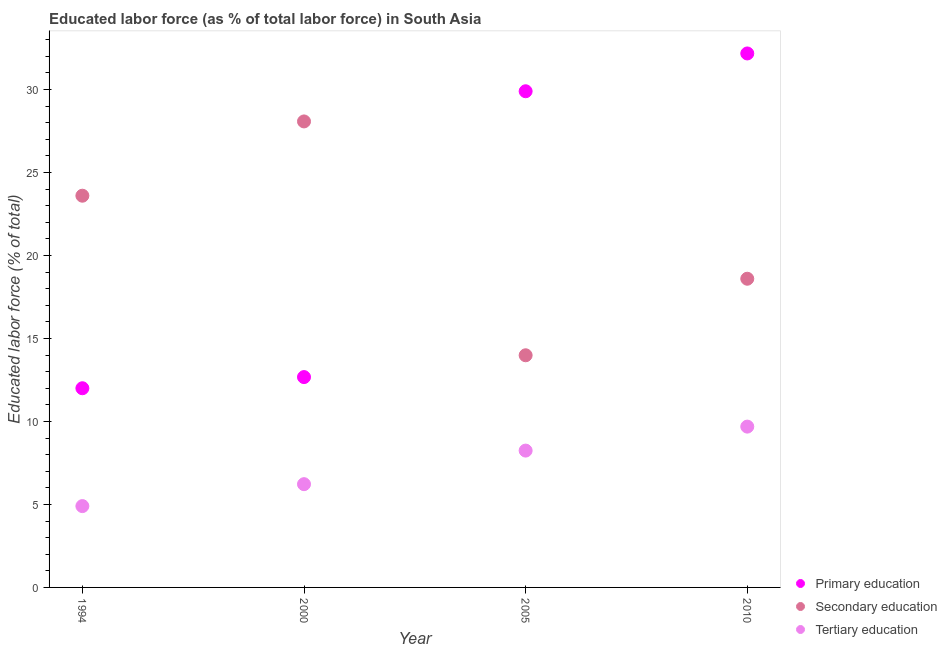How many different coloured dotlines are there?
Ensure brevity in your answer.  3. Is the number of dotlines equal to the number of legend labels?
Offer a very short reply. Yes. What is the percentage of labor force who received secondary education in 1994?
Keep it short and to the point. 23.6. Across all years, what is the maximum percentage of labor force who received secondary education?
Offer a terse response. 28.08. In which year was the percentage of labor force who received tertiary education maximum?
Provide a succinct answer. 2010. In which year was the percentage of labor force who received tertiary education minimum?
Ensure brevity in your answer.  1994. What is the total percentage of labor force who received tertiary education in the graph?
Ensure brevity in your answer.  29.05. What is the difference between the percentage of labor force who received secondary education in 1994 and that in 2010?
Make the answer very short. 5. What is the difference between the percentage of labor force who received primary education in 1994 and the percentage of labor force who received secondary education in 2010?
Keep it short and to the point. -6.6. What is the average percentage of labor force who received secondary education per year?
Ensure brevity in your answer.  21.06. In the year 2010, what is the difference between the percentage of labor force who received secondary education and percentage of labor force who received primary education?
Provide a succinct answer. -13.57. In how many years, is the percentage of labor force who received tertiary education greater than 12 %?
Provide a short and direct response. 0. What is the ratio of the percentage of labor force who received primary education in 2005 to that in 2010?
Your answer should be compact. 0.93. What is the difference between the highest and the second highest percentage of labor force who received tertiary education?
Make the answer very short. 1.45. What is the difference between the highest and the lowest percentage of labor force who received secondary education?
Your answer should be compact. 14.09. In how many years, is the percentage of labor force who received primary education greater than the average percentage of labor force who received primary education taken over all years?
Your answer should be very brief. 2. Is the sum of the percentage of labor force who received tertiary education in 1994 and 2005 greater than the maximum percentage of labor force who received secondary education across all years?
Your answer should be compact. No. Does the percentage of labor force who received tertiary education monotonically increase over the years?
Your answer should be compact. Yes. Is the percentage of labor force who received secondary education strictly greater than the percentage of labor force who received primary education over the years?
Provide a short and direct response. No. Is the percentage of labor force who received primary education strictly less than the percentage of labor force who received tertiary education over the years?
Your answer should be compact. No. How many dotlines are there?
Make the answer very short. 3. How many years are there in the graph?
Your response must be concise. 4. Does the graph contain any zero values?
Give a very brief answer. No. How many legend labels are there?
Your answer should be compact. 3. What is the title of the graph?
Give a very brief answer. Educated labor force (as % of total labor force) in South Asia. What is the label or title of the Y-axis?
Provide a succinct answer. Educated labor force (% of total). What is the Educated labor force (% of total) in Secondary education in 1994?
Give a very brief answer. 23.6. What is the Educated labor force (% of total) in Tertiary education in 1994?
Keep it short and to the point. 4.9. What is the Educated labor force (% of total) in Primary education in 2000?
Ensure brevity in your answer.  12.67. What is the Educated labor force (% of total) in Secondary education in 2000?
Provide a short and direct response. 28.08. What is the Educated labor force (% of total) in Tertiary education in 2000?
Give a very brief answer. 6.22. What is the Educated labor force (% of total) of Primary education in 2005?
Your answer should be very brief. 29.89. What is the Educated labor force (% of total) of Secondary education in 2005?
Keep it short and to the point. 13.99. What is the Educated labor force (% of total) in Tertiary education in 2005?
Provide a short and direct response. 8.24. What is the Educated labor force (% of total) in Primary education in 2010?
Your answer should be very brief. 32.17. What is the Educated labor force (% of total) of Secondary education in 2010?
Make the answer very short. 18.6. What is the Educated labor force (% of total) of Tertiary education in 2010?
Your answer should be very brief. 9.69. Across all years, what is the maximum Educated labor force (% of total) of Primary education?
Provide a succinct answer. 32.17. Across all years, what is the maximum Educated labor force (% of total) in Secondary education?
Offer a terse response. 28.08. Across all years, what is the maximum Educated labor force (% of total) of Tertiary education?
Keep it short and to the point. 9.69. Across all years, what is the minimum Educated labor force (% of total) in Primary education?
Keep it short and to the point. 12. Across all years, what is the minimum Educated labor force (% of total) of Secondary education?
Your response must be concise. 13.99. Across all years, what is the minimum Educated labor force (% of total) in Tertiary education?
Provide a succinct answer. 4.9. What is the total Educated labor force (% of total) of Primary education in the graph?
Provide a succinct answer. 86.74. What is the total Educated labor force (% of total) of Secondary education in the graph?
Your answer should be very brief. 84.26. What is the total Educated labor force (% of total) in Tertiary education in the graph?
Your response must be concise. 29.05. What is the difference between the Educated labor force (% of total) of Primary education in 1994 and that in 2000?
Provide a short and direct response. -0.67. What is the difference between the Educated labor force (% of total) in Secondary education in 1994 and that in 2000?
Offer a terse response. -4.48. What is the difference between the Educated labor force (% of total) of Tertiary education in 1994 and that in 2000?
Your response must be concise. -1.32. What is the difference between the Educated labor force (% of total) in Primary education in 1994 and that in 2005?
Offer a terse response. -17.89. What is the difference between the Educated labor force (% of total) of Secondary education in 1994 and that in 2005?
Give a very brief answer. 9.61. What is the difference between the Educated labor force (% of total) of Tertiary education in 1994 and that in 2005?
Offer a terse response. -3.34. What is the difference between the Educated labor force (% of total) of Primary education in 1994 and that in 2010?
Provide a short and direct response. -20.17. What is the difference between the Educated labor force (% of total) in Secondary education in 1994 and that in 2010?
Provide a short and direct response. 5. What is the difference between the Educated labor force (% of total) of Tertiary education in 1994 and that in 2010?
Make the answer very short. -4.79. What is the difference between the Educated labor force (% of total) in Primary education in 2000 and that in 2005?
Keep it short and to the point. -17.22. What is the difference between the Educated labor force (% of total) in Secondary education in 2000 and that in 2005?
Provide a short and direct response. 14.09. What is the difference between the Educated labor force (% of total) of Tertiary education in 2000 and that in 2005?
Your response must be concise. -2.02. What is the difference between the Educated labor force (% of total) of Primary education in 2000 and that in 2010?
Ensure brevity in your answer.  -19.5. What is the difference between the Educated labor force (% of total) of Secondary education in 2000 and that in 2010?
Keep it short and to the point. 9.48. What is the difference between the Educated labor force (% of total) in Tertiary education in 2000 and that in 2010?
Your answer should be very brief. -3.47. What is the difference between the Educated labor force (% of total) in Primary education in 2005 and that in 2010?
Provide a short and direct response. -2.28. What is the difference between the Educated labor force (% of total) of Secondary education in 2005 and that in 2010?
Offer a very short reply. -4.61. What is the difference between the Educated labor force (% of total) of Tertiary education in 2005 and that in 2010?
Your response must be concise. -1.45. What is the difference between the Educated labor force (% of total) of Primary education in 1994 and the Educated labor force (% of total) of Secondary education in 2000?
Make the answer very short. -16.08. What is the difference between the Educated labor force (% of total) in Primary education in 1994 and the Educated labor force (% of total) in Tertiary education in 2000?
Offer a terse response. 5.78. What is the difference between the Educated labor force (% of total) in Secondary education in 1994 and the Educated labor force (% of total) in Tertiary education in 2000?
Your answer should be very brief. 17.38. What is the difference between the Educated labor force (% of total) of Primary education in 1994 and the Educated labor force (% of total) of Secondary education in 2005?
Offer a very short reply. -1.99. What is the difference between the Educated labor force (% of total) in Primary education in 1994 and the Educated labor force (% of total) in Tertiary education in 2005?
Offer a terse response. 3.76. What is the difference between the Educated labor force (% of total) of Secondary education in 1994 and the Educated labor force (% of total) of Tertiary education in 2005?
Your response must be concise. 15.36. What is the difference between the Educated labor force (% of total) of Primary education in 1994 and the Educated labor force (% of total) of Secondary education in 2010?
Make the answer very short. -6.6. What is the difference between the Educated labor force (% of total) in Primary education in 1994 and the Educated labor force (% of total) in Tertiary education in 2010?
Ensure brevity in your answer.  2.31. What is the difference between the Educated labor force (% of total) in Secondary education in 1994 and the Educated labor force (% of total) in Tertiary education in 2010?
Ensure brevity in your answer.  13.91. What is the difference between the Educated labor force (% of total) of Primary education in 2000 and the Educated labor force (% of total) of Secondary education in 2005?
Offer a terse response. -1.31. What is the difference between the Educated labor force (% of total) in Primary education in 2000 and the Educated labor force (% of total) in Tertiary education in 2005?
Offer a terse response. 4.43. What is the difference between the Educated labor force (% of total) of Secondary education in 2000 and the Educated labor force (% of total) of Tertiary education in 2005?
Your answer should be very brief. 19.83. What is the difference between the Educated labor force (% of total) in Primary education in 2000 and the Educated labor force (% of total) in Secondary education in 2010?
Give a very brief answer. -5.93. What is the difference between the Educated labor force (% of total) of Primary education in 2000 and the Educated labor force (% of total) of Tertiary education in 2010?
Your answer should be very brief. 2.98. What is the difference between the Educated labor force (% of total) in Secondary education in 2000 and the Educated labor force (% of total) in Tertiary education in 2010?
Your answer should be compact. 18.39. What is the difference between the Educated labor force (% of total) of Primary education in 2005 and the Educated labor force (% of total) of Secondary education in 2010?
Your response must be concise. 11.3. What is the difference between the Educated labor force (% of total) in Primary education in 2005 and the Educated labor force (% of total) in Tertiary education in 2010?
Make the answer very short. 20.2. What is the difference between the Educated labor force (% of total) of Secondary education in 2005 and the Educated labor force (% of total) of Tertiary education in 2010?
Make the answer very short. 4.3. What is the average Educated labor force (% of total) in Primary education per year?
Make the answer very short. 21.68. What is the average Educated labor force (% of total) in Secondary education per year?
Your answer should be compact. 21.06. What is the average Educated labor force (% of total) in Tertiary education per year?
Offer a terse response. 7.26. In the year 2000, what is the difference between the Educated labor force (% of total) of Primary education and Educated labor force (% of total) of Secondary education?
Give a very brief answer. -15.4. In the year 2000, what is the difference between the Educated labor force (% of total) of Primary education and Educated labor force (% of total) of Tertiary education?
Make the answer very short. 6.45. In the year 2000, what is the difference between the Educated labor force (% of total) of Secondary education and Educated labor force (% of total) of Tertiary education?
Your answer should be compact. 21.85. In the year 2005, what is the difference between the Educated labor force (% of total) of Primary education and Educated labor force (% of total) of Secondary education?
Offer a terse response. 15.91. In the year 2005, what is the difference between the Educated labor force (% of total) in Primary education and Educated labor force (% of total) in Tertiary education?
Give a very brief answer. 21.65. In the year 2005, what is the difference between the Educated labor force (% of total) of Secondary education and Educated labor force (% of total) of Tertiary education?
Provide a short and direct response. 5.74. In the year 2010, what is the difference between the Educated labor force (% of total) of Primary education and Educated labor force (% of total) of Secondary education?
Offer a very short reply. 13.57. In the year 2010, what is the difference between the Educated labor force (% of total) of Primary education and Educated labor force (% of total) of Tertiary education?
Give a very brief answer. 22.48. In the year 2010, what is the difference between the Educated labor force (% of total) in Secondary education and Educated labor force (% of total) in Tertiary education?
Your answer should be very brief. 8.91. What is the ratio of the Educated labor force (% of total) in Primary education in 1994 to that in 2000?
Make the answer very short. 0.95. What is the ratio of the Educated labor force (% of total) in Secondary education in 1994 to that in 2000?
Your response must be concise. 0.84. What is the ratio of the Educated labor force (% of total) of Tertiary education in 1994 to that in 2000?
Your answer should be very brief. 0.79. What is the ratio of the Educated labor force (% of total) in Primary education in 1994 to that in 2005?
Offer a terse response. 0.4. What is the ratio of the Educated labor force (% of total) in Secondary education in 1994 to that in 2005?
Give a very brief answer. 1.69. What is the ratio of the Educated labor force (% of total) of Tertiary education in 1994 to that in 2005?
Your response must be concise. 0.59. What is the ratio of the Educated labor force (% of total) in Primary education in 1994 to that in 2010?
Your answer should be very brief. 0.37. What is the ratio of the Educated labor force (% of total) of Secondary education in 1994 to that in 2010?
Offer a terse response. 1.27. What is the ratio of the Educated labor force (% of total) of Tertiary education in 1994 to that in 2010?
Make the answer very short. 0.51. What is the ratio of the Educated labor force (% of total) in Primary education in 2000 to that in 2005?
Your response must be concise. 0.42. What is the ratio of the Educated labor force (% of total) of Secondary education in 2000 to that in 2005?
Make the answer very short. 2.01. What is the ratio of the Educated labor force (% of total) in Tertiary education in 2000 to that in 2005?
Provide a short and direct response. 0.75. What is the ratio of the Educated labor force (% of total) in Primary education in 2000 to that in 2010?
Keep it short and to the point. 0.39. What is the ratio of the Educated labor force (% of total) in Secondary education in 2000 to that in 2010?
Offer a terse response. 1.51. What is the ratio of the Educated labor force (% of total) in Tertiary education in 2000 to that in 2010?
Provide a short and direct response. 0.64. What is the ratio of the Educated labor force (% of total) in Primary education in 2005 to that in 2010?
Ensure brevity in your answer.  0.93. What is the ratio of the Educated labor force (% of total) of Secondary education in 2005 to that in 2010?
Offer a terse response. 0.75. What is the ratio of the Educated labor force (% of total) in Tertiary education in 2005 to that in 2010?
Make the answer very short. 0.85. What is the difference between the highest and the second highest Educated labor force (% of total) in Primary education?
Ensure brevity in your answer.  2.28. What is the difference between the highest and the second highest Educated labor force (% of total) of Secondary education?
Keep it short and to the point. 4.48. What is the difference between the highest and the second highest Educated labor force (% of total) of Tertiary education?
Provide a short and direct response. 1.45. What is the difference between the highest and the lowest Educated labor force (% of total) in Primary education?
Make the answer very short. 20.17. What is the difference between the highest and the lowest Educated labor force (% of total) in Secondary education?
Your answer should be compact. 14.09. What is the difference between the highest and the lowest Educated labor force (% of total) in Tertiary education?
Your response must be concise. 4.79. 